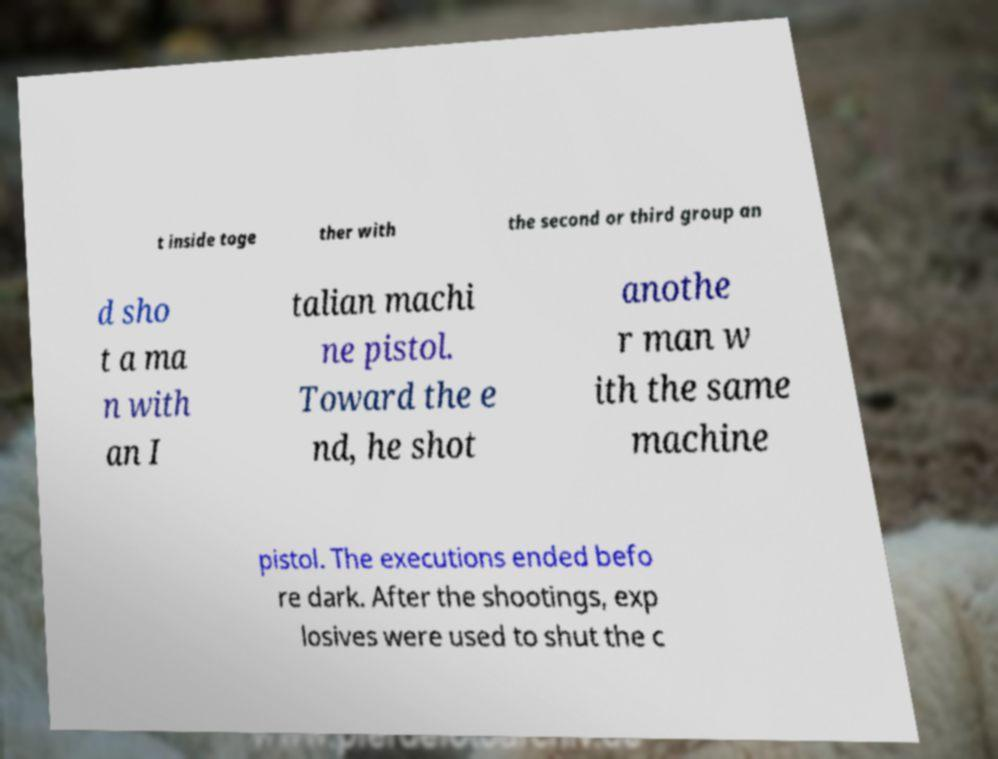Please identify and transcribe the text found in this image. t inside toge ther with the second or third group an d sho t a ma n with an I talian machi ne pistol. Toward the e nd, he shot anothe r man w ith the same machine pistol. The executions ended befo re dark. After the shootings, exp losives were used to shut the c 